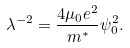Convert formula to latex. <formula><loc_0><loc_0><loc_500><loc_500>\lambda ^ { - 2 } = \frac { 4 \mu _ { 0 } e ^ { 2 } } { m ^ { * } } \psi _ { 0 } ^ { 2 } .</formula> 